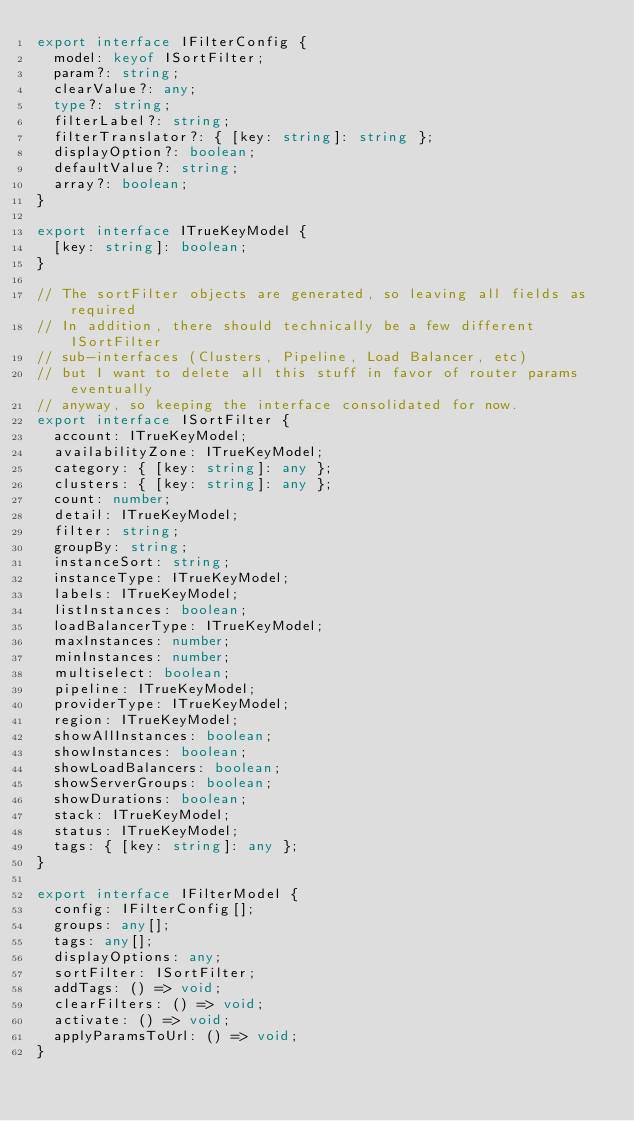<code> <loc_0><loc_0><loc_500><loc_500><_TypeScript_>export interface IFilterConfig {
  model: keyof ISortFilter;
  param?: string;
  clearValue?: any;
  type?: string;
  filterLabel?: string;
  filterTranslator?: { [key: string]: string };
  displayOption?: boolean;
  defaultValue?: string;
  array?: boolean;
}

export interface ITrueKeyModel {
  [key: string]: boolean;
}

// The sortFilter objects are generated, so leaving all fields as required
// In addition, there should technically be a few different ISortFilter
// sub-interfaces (Clusters, Pipeline, Load Balancer, etc)
// but I want to delete all this stuff in favor of router params eventually
// anyway, so keeping the interface consolidated for now.
export interface ISortFilter {
  account: ITrueKeyModel;
  availabilityZone: ITrueKeyModel;
  category: { [key: string]: any };
  clusters: { [key: string]: any };
  count: number;
  detail: ITrueKeyModel;
  filter: string;
  groupBy: string;
  instanceSort: string;
  instanceType: ITrueKeyModel;
  labels: ITrueKeyModel;
  listInstances: boolean;
  loadBalancerType: ITrueKeyModel;
  maxInstances: number;
  minInstances: number;
  multiselect: boolean;
  pipeline: ITrueKeyModel;
  providerType: ITrueKeyModel;
  region: ITrueKeyModel;
  showAllInstances: boolean;
  showInstances: boolean;
  showLoadBalancers: boolean;
  showServerGroups: boolean;
  showDurations: boolean;
  stack: ITrueKeyModel;
  status: ITrueKeyModel;
  tags: { [key: string]: any };
}

export interface IFilterModel {
  config: IFilterConfig[];
  groups: any[];
  tags: any[];
  displayOptions: any;
  sortFilter: ISortFilter;
  addTags: () => void;
  clearFilters: () => void;
  activate: () => void;
  applyParamsToUrl: () => void;
}
</code> 